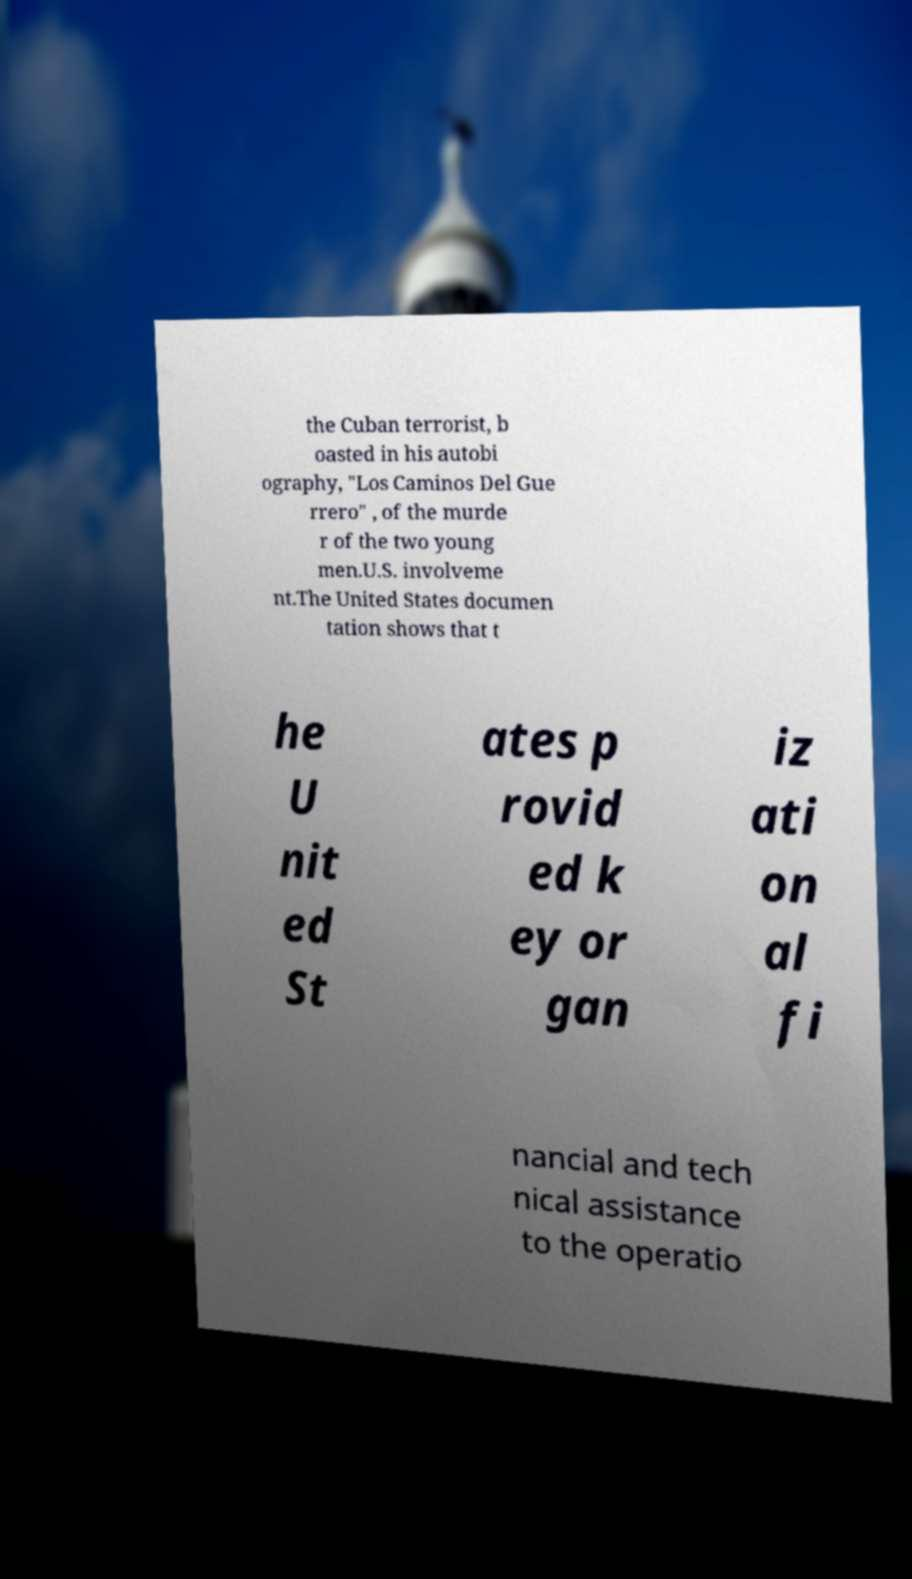Can you read and provide the text displayed in the image?This photo seems to have some interesting text. Can you extract and type it out for me? the Cuban terrorist, b oasted in his autobi ography, "Los Caminos Del Gue rrero" , of the murde r of the two young men.U.S. involveme nt.The United States documen tation shows that t he U nit ed St ates p rovid ed k ey or gan iz ati on al fi nancial and tech nical assistance to the operatio 